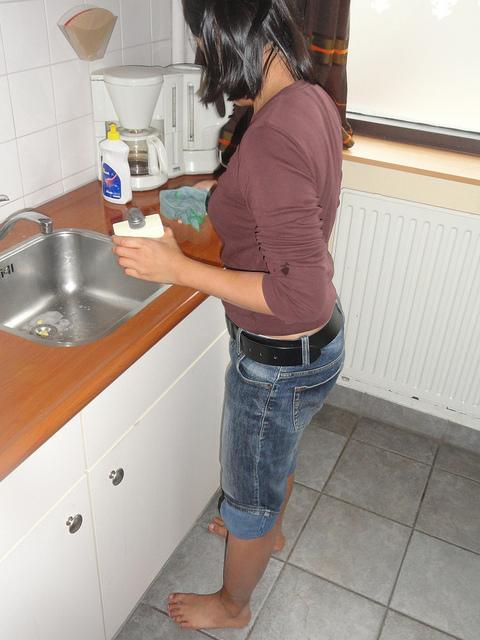What is this room most likely called? kitchen 